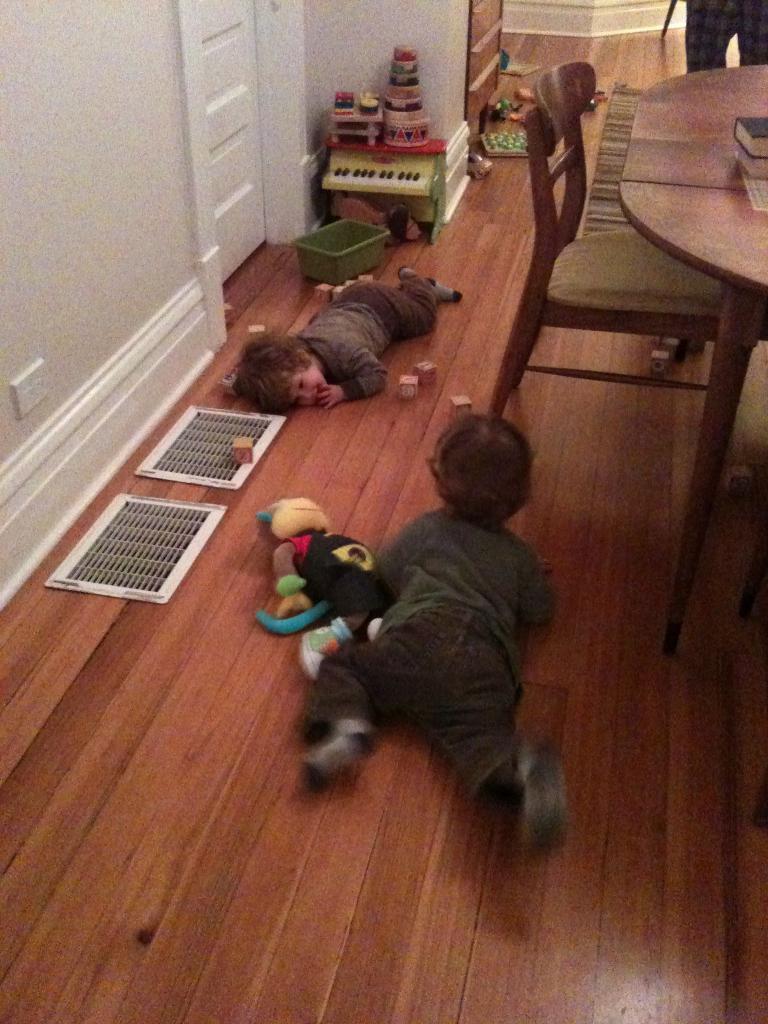How would you summarize this image in a sentence or two? There are two children lying on the floor. There are many toys, baskets and other items on the floor. In the left side there is a wall and a door. On the right side there is a table and a chair. On the table there are books. 